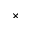<formula> <loc_0><loc_0><loc_500><loc_500>\times</formula> 